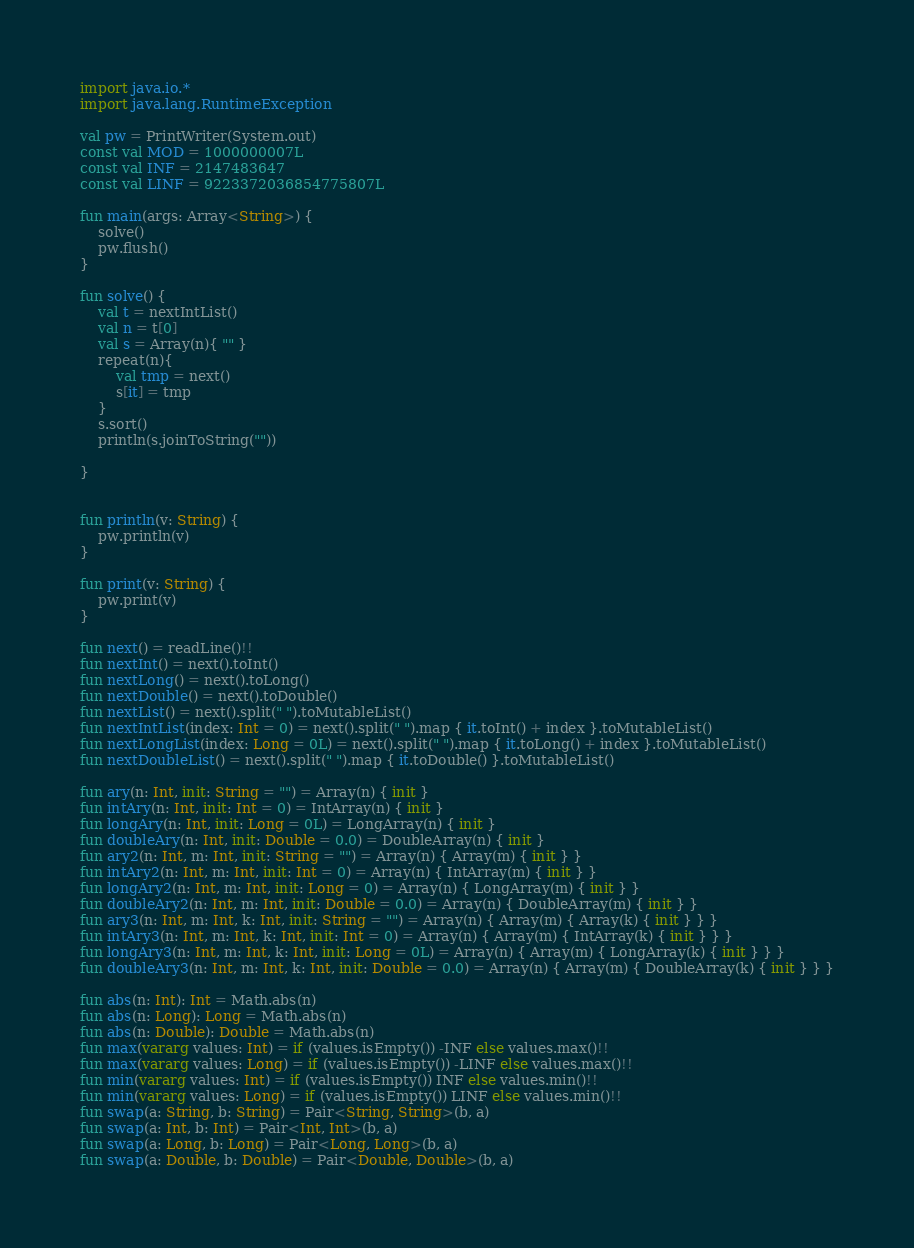Convert code to text. <code><loc_0><loc_0><loc_500><loc_500><_Kotlin_>import java.io.*
import java.lang.RuntimeException

val pw = PrintWriter(System.out)
const val MOD = 1000000007L
const val INF = 2147483647
const val LINF = 9223372036854775807L

fun main(args: Array<String>) {
    solve()
    pw.flush()
}

fun solve() {
    val t = nextIntList()
    val n = t[0]
    val s = Array(n){ "" }
    repeat(n){
        val tmp = next()
        s[it] = tmp
    }
    s.sort()
    println(s.joinToString(""))

}


fun println(v: String) {
    pw.println(v)
}

fun print(v: String) {
    pw.print(v)
}

fun next() = readLine()!!
fun nextInt() = next().toInt()
fun nextLong() = next().toLong()
fun nextDouble() = next().toDouble()
fun nextList() = next().split(" ").toMutableList()
fun nextIntList(index: Int = 0) = next().split(" ").map { it.toInt() + index }.toMutableList()
fun nextLongList(index: Long = 0L) = next().split(" ").map { it.toLong() + index }.toMutableList()
fun nextDoubleList() = next().split(" ").map { it.toDouble() }.toMutableList()

fun ary(n: Int, init: String = "") = Array(n) { init }
fun intAry(n: Int, init: Int = 0) = IntArray(n) { init }
fun longAry(n: Int, init: Long = 0L) = LongArray(n) { init }
fun doubleAry(n: Int, init: Double = 0.0) = DoubleArray(n) { init }
fun ary2(n: Int, m: Int, init: String = "") = Array(n) { Array(m) { init } }
fun intAry2(n: Int, m: Int, init: Int = 0) = Array(n) { IntArray(m) { init } }
fun longAry2(n: Int, m: Int, init: Long = 0) = Array(n) { LongArray(m) { init } }
fun doubleAry2(n: Int, m: Int, init: Double = 0.0) = Array(n) { DoubleArray(m) { init } }
fun ary3(n: Int, m: Int, k: Int, init: String = "") = Array(n) { Array(m) { Array(k) { init } } }
fun intAry3(n: Int, m: Int, k: Int, init: Int = 0) = Array(n) { Array(m) { IntArray(k) { init } } }
fun longAry3(n: Int, m: Int, k: Int, init: Long = 0L) = Array(n) { Array(m) { LongArray(k) { init } } }
fun doubleAry3(n: Int, m: Int, k: Int, init: Double = 0.0) = Array(n) { Array(m) { DoubleArray(k) { init } } }

fun abs(n: Int): Int = Math.abs(n)
fun abs(n: Long): Long = Math.abs(n)
fun abs(n: Double): Double = Math.abs(n)
fun max(vararg values: Int) = if (values.isEmpty()) -INF else values.max()!!
fun max(vararg values: Long) = if (values.isEmpty()) -LINF else values.max()!!
fun min(vararg values: Int) = if (values.isEmpty()) INF else values.min()!!
fun min(vararg values: Long) = if (values.isEmpty()) LINF else values.min()!!
fun swap(a: String, b: String) = Pair<String, String>(b, a)
fun swap(a: Int, b: Int) = Pair<Int, Int>(b, a)
fun swap(a: Long, b: Long) = Pair<Long, Long>(b, a)
fun swap(a: Double, b: Double) = Pair<Double, Double>(b, a)</code> 